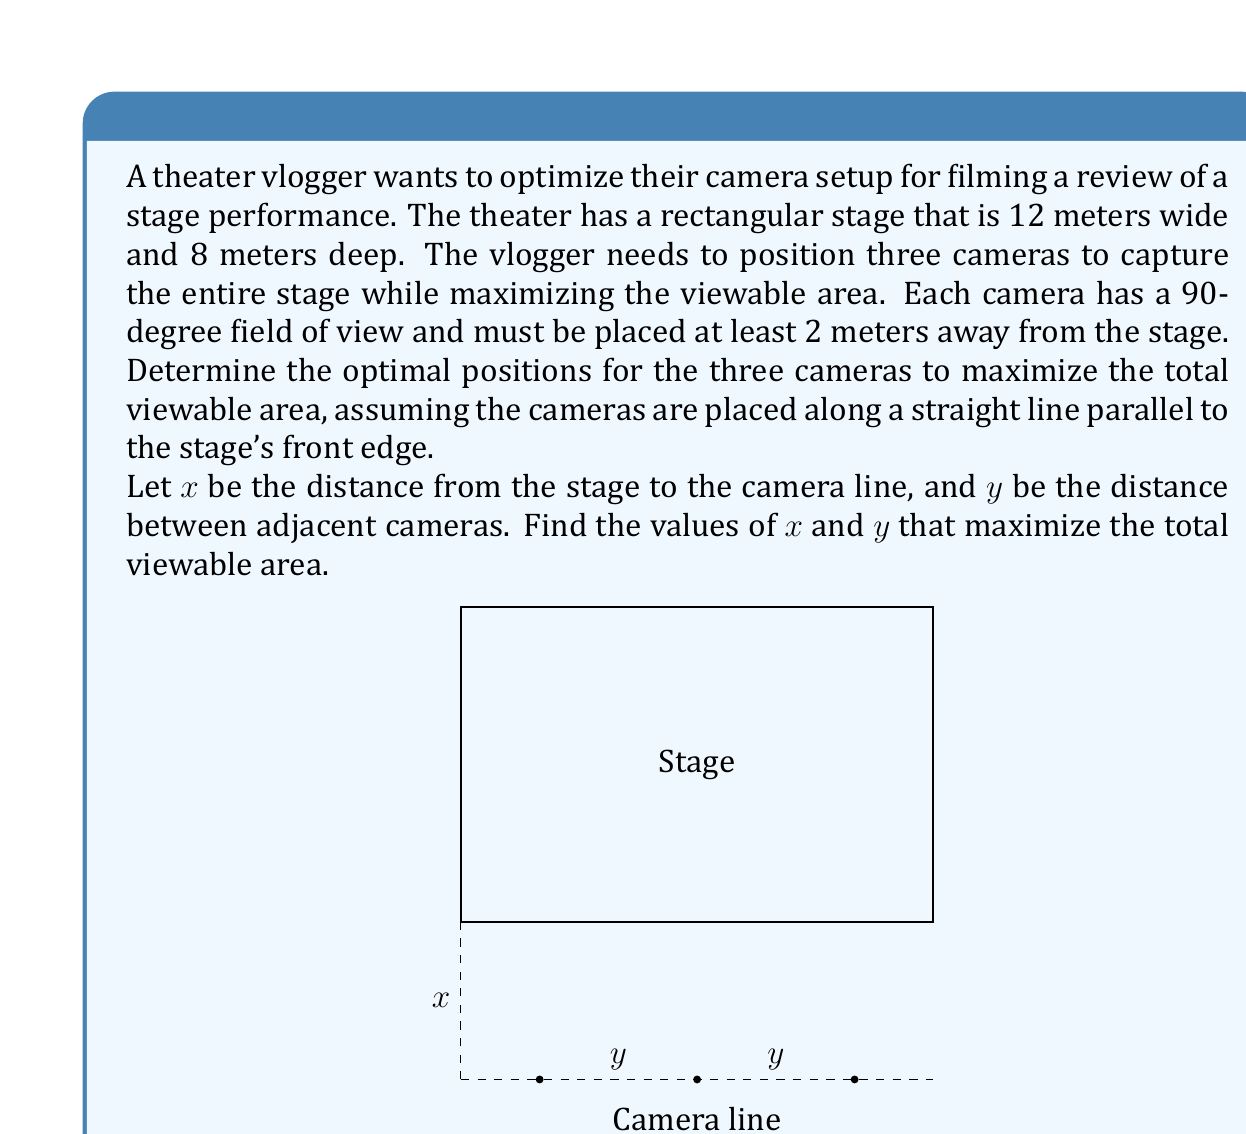Show me your answer to this math problem. To solve this optimization problem, we'll follow these steps:

1) First, let's express the viewable area in terms of $x$ and $y$:
   Each camera covers a triangular area with a base of $\frac{2x}{\sqrt{3}}$ (due to the 90-degree field of view).

2) The total viewable width is:
   $$W = 3 \cdot \frac{2x}{\sqrt{3}} = \frac{2x\sqrt{3}}{3}$$

3) For full coverage, this should equal the stage width:
   $$\frac{2x\sqrt{3}}{3} = 12$$

4) Solving for $x$:
   $$x = \frac{12 \cdot 3}{2\sqrt{3}} = 3\sqrt{3} \approx 5.2 \text{ meters}$$

5) Now, to maximize the viewable area, we need to minimize the overlap between cameras. This occurs when the cameras are evenly spaced and their fields of view just touch at the stage's front edge.

6) The distance $y$ between cameras can be found using the tangent function:
   $$\tan(45°) = \frac{y/2}{x}$$
   $$y = 2x \tan(45°) = 2x$$

7) Substituting our value for $x$:
   $$y = 2(3\sqrt{3}) = 6\sqrt{3} \approx 10.4 \text{ meters}$$

8) We need to check if this setup fits within the stage width:
   $$2y = 12\sqrt{3} \approx 20.8 \text{ meters}$$
   This is greater than the stage width of 12 meters, so we need to adjust.

9) The maximum possible $y$ is half the stage width:
   $$y = 6 \text{ meters}$$

10) Recalculating $x$ based on this $y$:
    $$x = \frac{y}{2} = 3 \text{ meters}$$

11) This satisfies our constraint of $x \geq 2$ meters.
Answer: The optimal camera positions are:
$x = 3 \text{ meters}$ (distance from stage to camera line)
$y = 6 \text{ meters}$ (distance between adjacent cameras) 